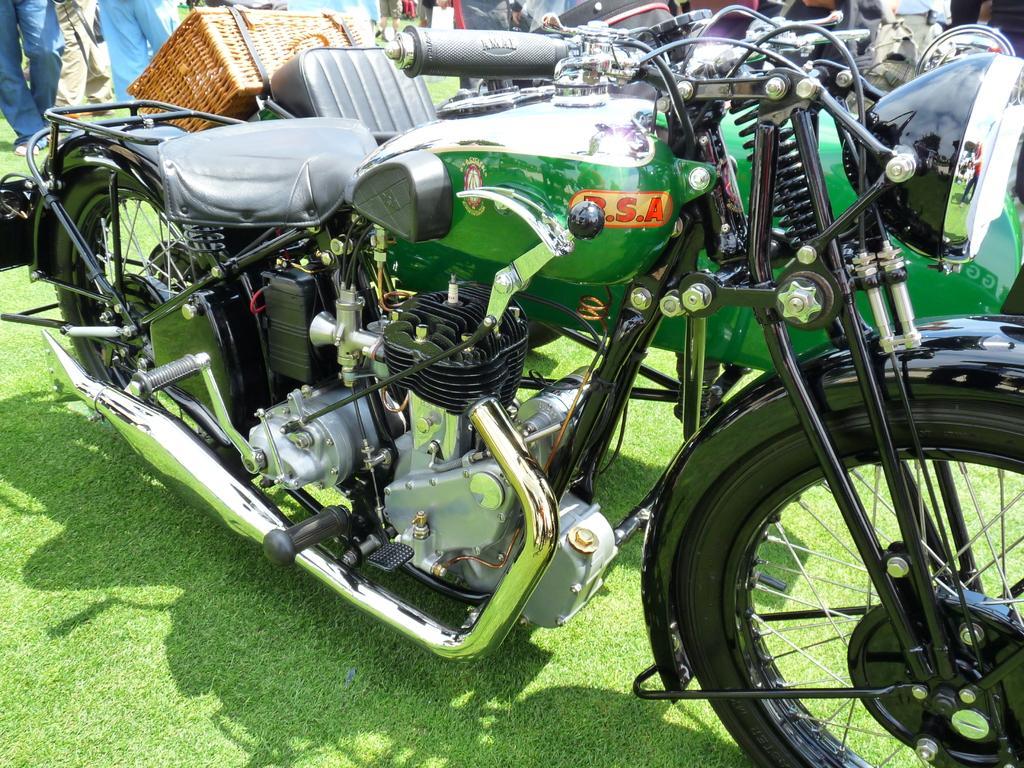Describe this image in one or two sentences. In this picture there is a bike, beside that I can see the baskets, seats and other objects. At the top I can see many people who are standing on the ground. At the bottom I can see the green grass. 